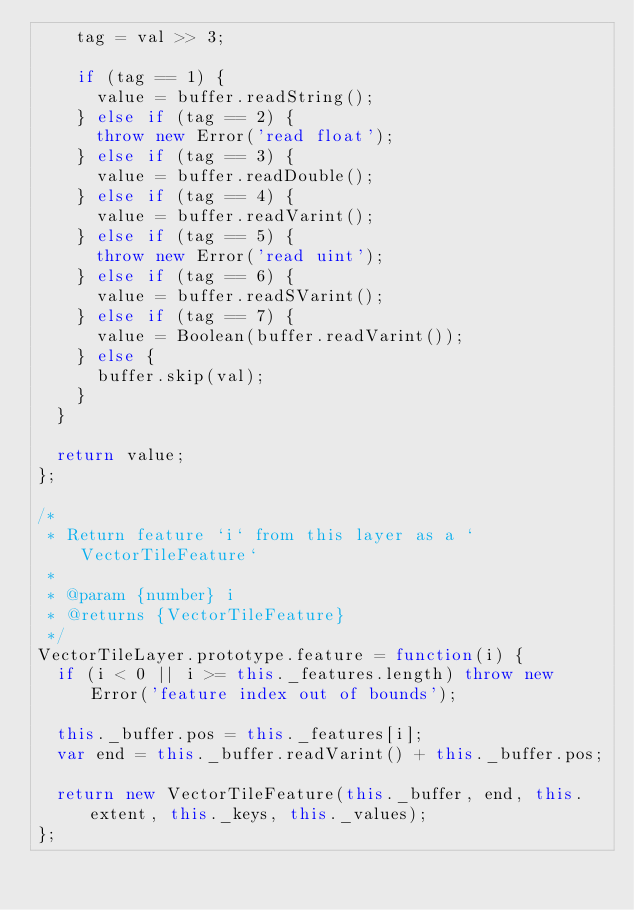<code> <loc_0><loc_0><loc_500><loc_500><_JavaScript_>    tag = val >> 3;

    if (tag == 1) {
      value = buffer.readString();
    } else if (tag == 2) {
      throw new Error('read float');
    } else if (tag == 3) {
      value = buffer.readDouble();
    } else if (tag == 4) {
      value = buffer.readVarint();
    } else if (tag == 5) {
      throw new Error('read uint');
    } else if (tag == 6) {
      value = buffer.readSVarint();
    } else if (tag == 7) {
      value = Boolean(buffer.readVarint());
    } else {
      buffer.skip(val);
    }
  }

  return value;
};

/*
 * Return feature `i` from this layer as a `VectorTileFeature`
 *
 * @param {number} i
 * @returns {VectorTileFeature}
 */
VectorTileLayer.prototype.feature = function(i) {
  if (i < 0 || i >= this._features.length) throw new Error('feature index out of bounds');

  this._buffer.pos = this._features[i];
  var end = this._buffer.readVarint() + this._buffer.pos;

  return new VectorTileFeature(this._buffer, end, this.extent, this._keys, this._values);
};
</code> 